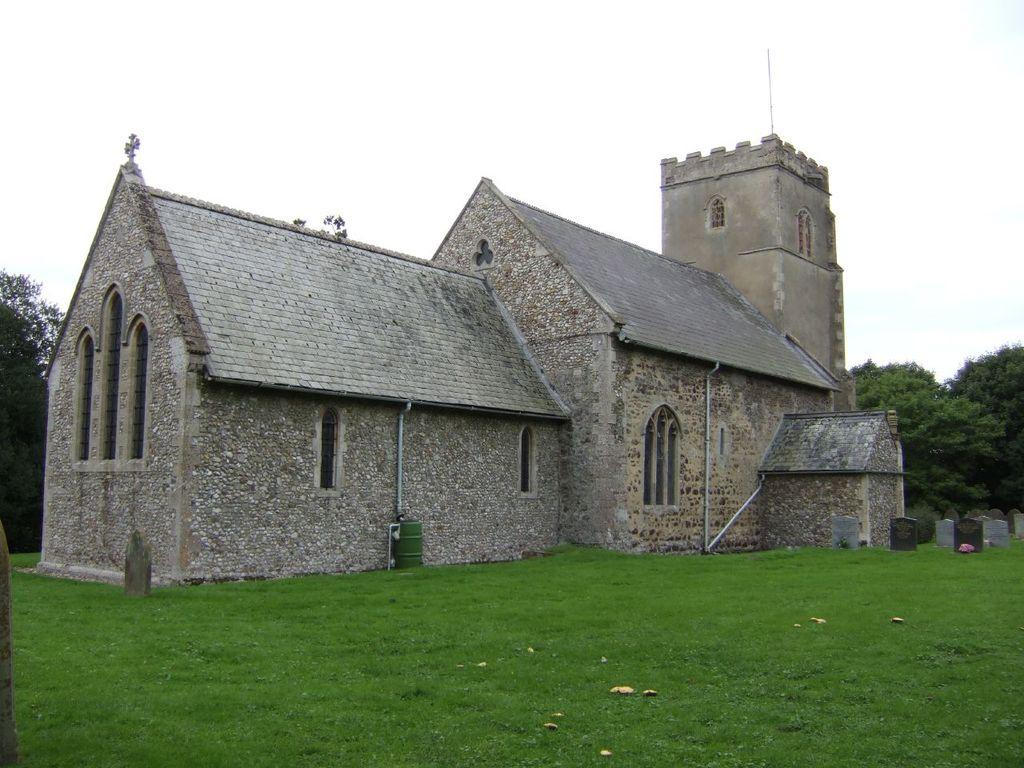What type of vegetation can be seen in the image? There is grass in the image. What type of structure is present in the image? There is a house in the image. What can be seen in the background of the image? There are trees and the sky visible in the background of the image. What type of prison can be seen in the image? There is no prison present in the image. What thrilling activity is taking place in the image? There is no thrilling activity depicted in the image; it features a house, grass, trees, and the sky. 